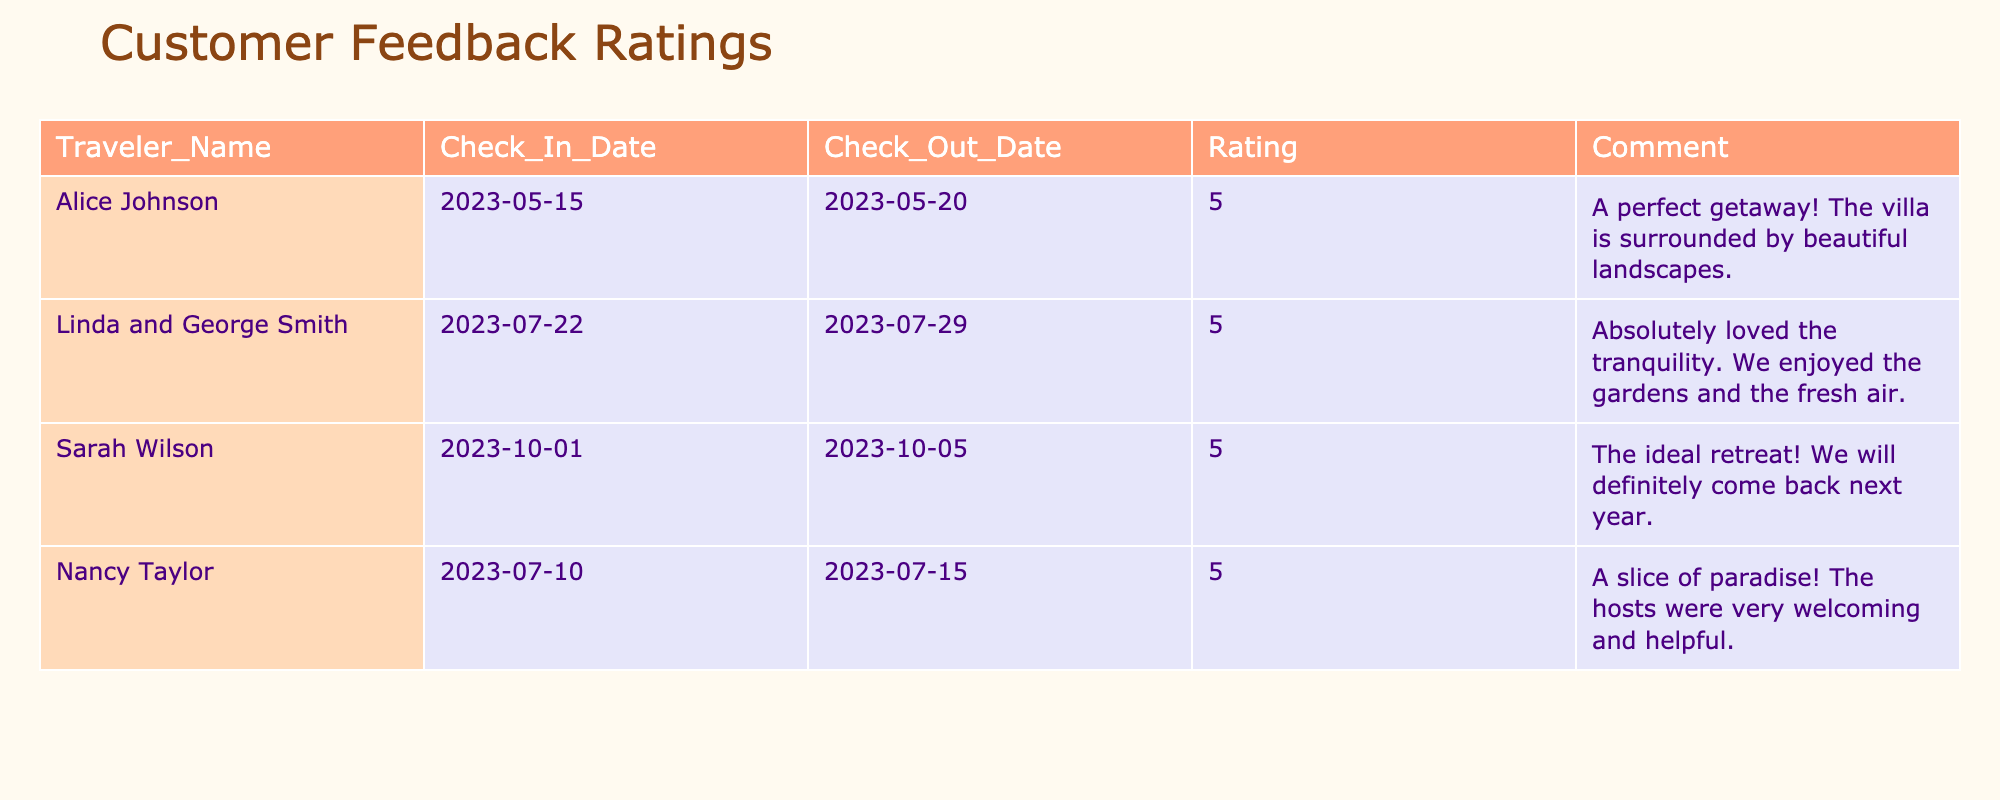What is the highest rating given by any traveler? The highest rating in the table is from Alice Johnson, Linda and George Smith, Sarah Wilson, and Nancy Taylor, all of whom gave a rating of 5.
Answer: 5 How many travelers rated their stay as 5 stars? There are four travelers listed: Alice Johnson, Linda and George Smith, Sarah Wilson, and Nancy Taylor. Each rated their stay 5 stars.
Answer: 4 What was the reason Sarah Wilson cited for wanting to return? Sarah Wilson's comment states she found the villa to be "The ideal retreat!" which indicates her satisfaction and desire to return.
Answer: Yes Which travelers expressed appreciation for the serenity of the villa? Linda and George Smith mentioned they "absolutely loved the tranquility," and Nancy Taylor described the villa as "A slice of paradise," indicating their appreciation for serenity.
Answer: Linda and George Smith and Nancy Taylor What is the average rating given by the travelers? All travelers gave a rating of 5 stars, so the average is also 5. The sum is (5 + 5 + 5 + 5) = 20, and there are 4 travelers, so 20 divided by 4 equals 5.
Answer: 5 